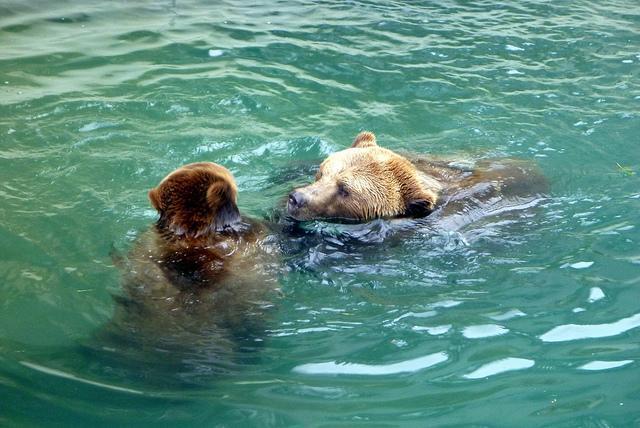How many bears are there?
Give a very brief answer. 2. How many bears are in the photo?
Give a very brief answer. 2. 